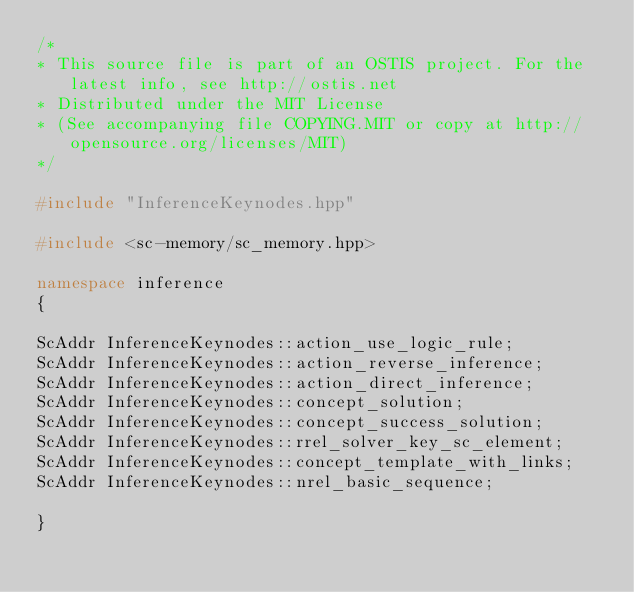Convert code to text. <code><loc_0><loc_0><loc_500><loc_500><_C++_>/*
* This source file is part of an OSTIS project. For the latest info, see http://ostis.net
* Distributed under the MIT License
* (See accompanying file COPYING.MIT or copy at http://opensource.org/licenses/MIT)
*/

#include "InferenceKeynodes.hpp"

#include <sc-memory/sc_memory.hpp>

namespace inference
{

ScAddr InferenceKeynodes::action_use_logic_rule;
ScAddr InferenceKeynodes::action_reverse_inference;
ScAddr InferenceKeynodes::action_direct_inference;
ScAddr InferenceKeynodes::concept_solution;
ScAddr InferenceKeynodes::concept_success_solution;
ScAddr InferenceKeynodes::rrel_solver_key_sc_element;
ScAddr InferenceKeynodes::concept_template_with_links;
ScAddr InferenceKeynodes::nrel_basic_sequence;

}
</code> 